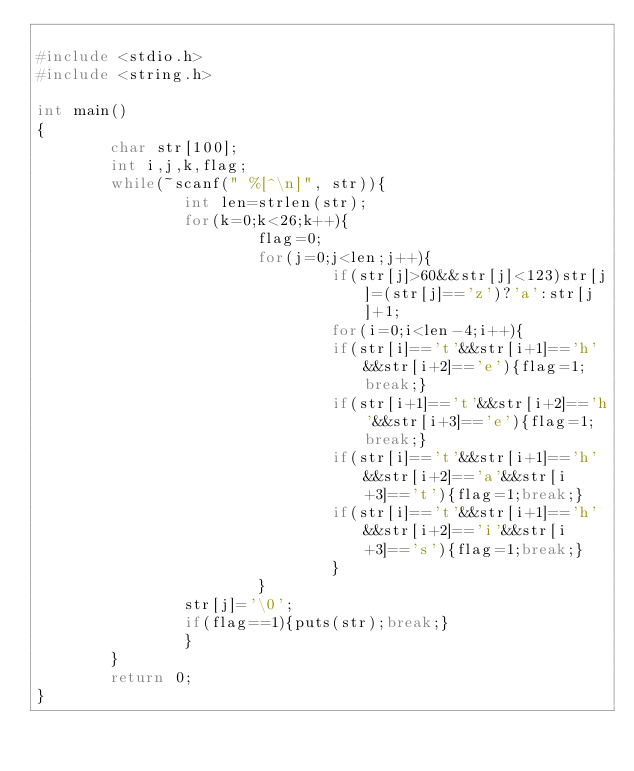Convert code to text. <code><loc_0><loc_0><loc_500><loc_500><_C_>
#include <stdio.h>
#include <string.h>

int main()
{
        char str[100];
        int i,j,k,flag;
        while(~scanf(" %[^\n]", str)){
                int len=strlen(str);
                for(k=0;k<26;k++){
                        flag=0;
                        for(j=0;j<len;j++){
                                if(str[j]>60&&str[j]<123)str[j]=(str[j]=='z')?'a':str[j]+1;
                                for(i=0;i<len-4;i++){
                                if(str[i]=='t'&&str[i+1]=='h'&&str[i+2]=='e'){flag=1;break;}
                                if(str[i+1]=='t'&&str[i+2]=='h'&&str[i+3]=='e'){flag=1;break;}
                                if(str[i]=='t'&&str[i+1]=='h'&&str[i+2]=='a'&&str[i+3]=='t'){flag=1;break;}
                                if(str[i]=='t'&&str[i+1]=='h'&&str[i+2]=='i'&&str[i+3]=='s'){flag=1;break;}
                                }
                        }
                str[j]='\0';
                if(flag==1){puts(str);break;}
                }
        }
        return 0;
}</code> 